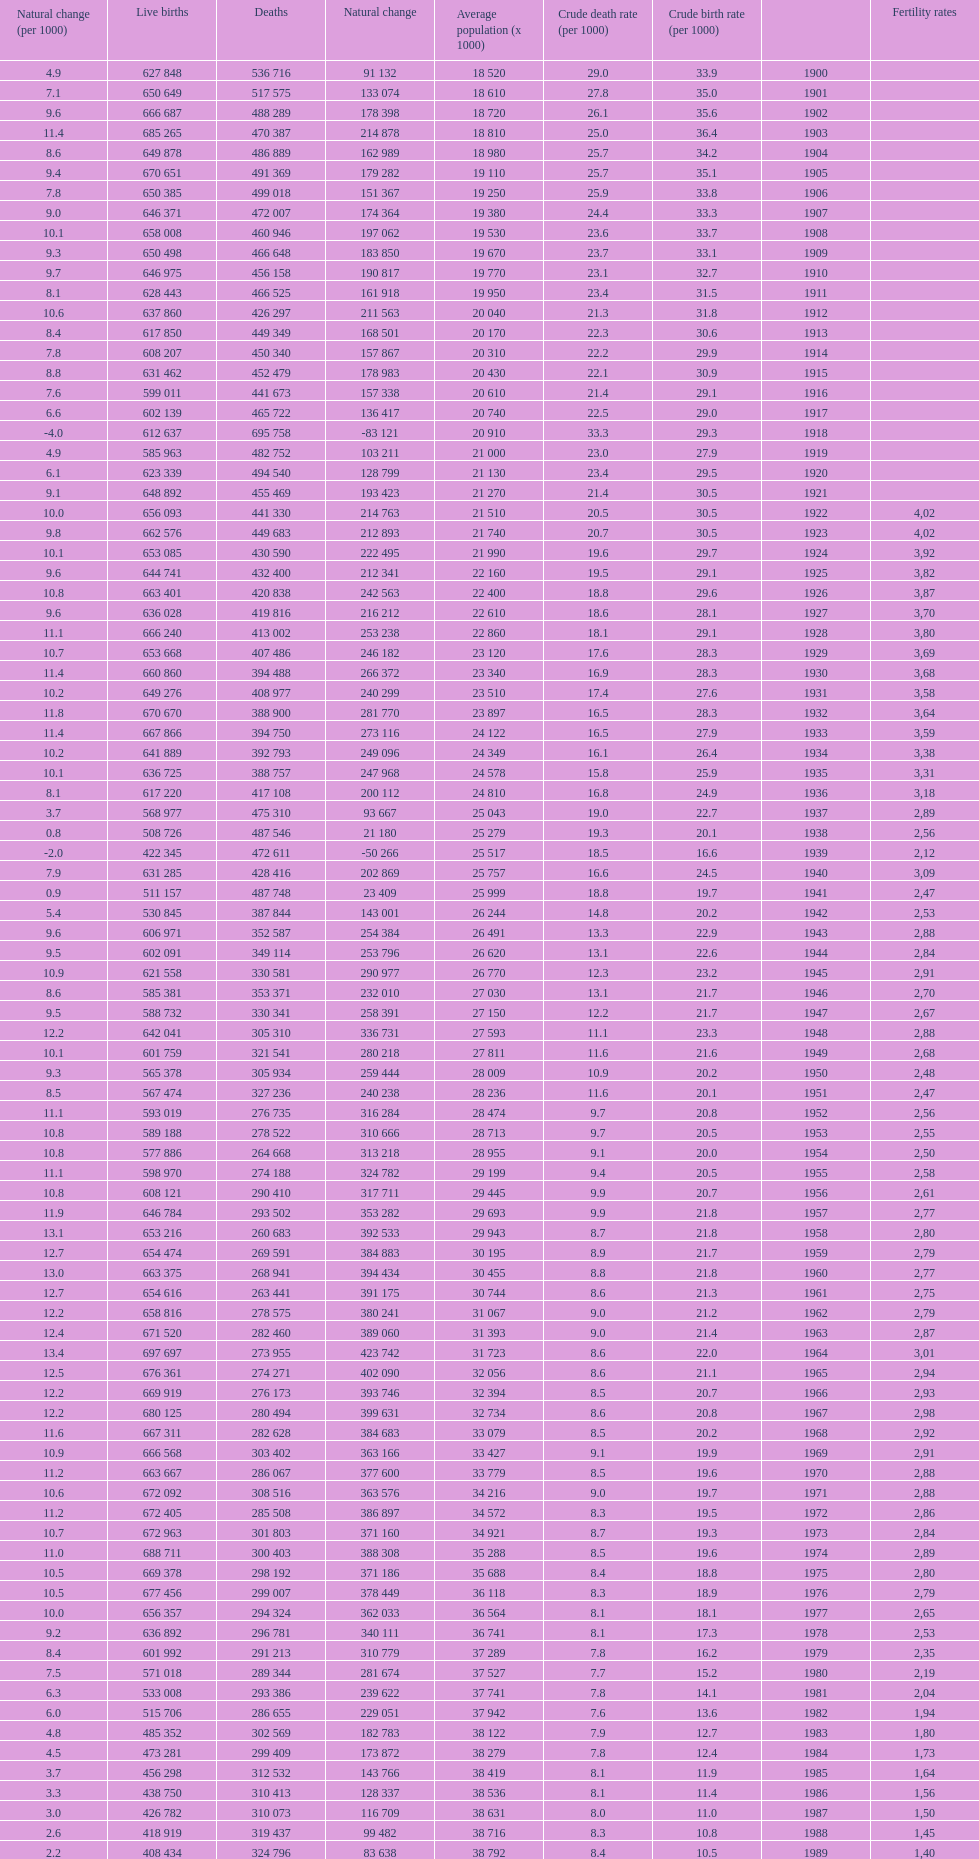In which year did spain show the highest number of live births over deaths? 1964. 